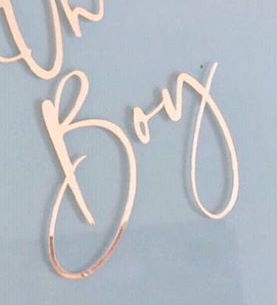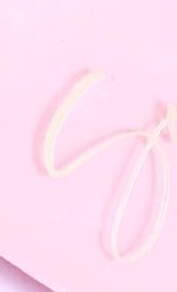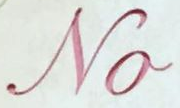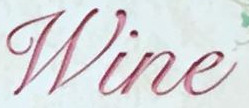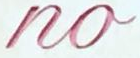What words can you see in these images in sequence, separated by a semicolon? Boy; S; No; Wine; no 